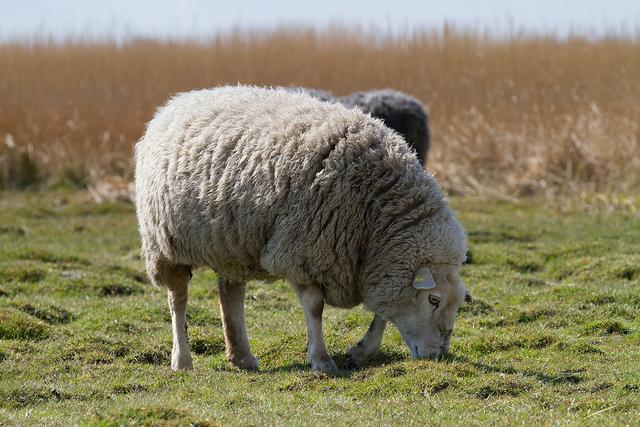How many garden hoses are there?
Give a very brief answer. 0. How many sheep can be seen?
Give a very brief answer. 2. How many chairs have a checkered pattern?
Give a very brief answer. 0. 